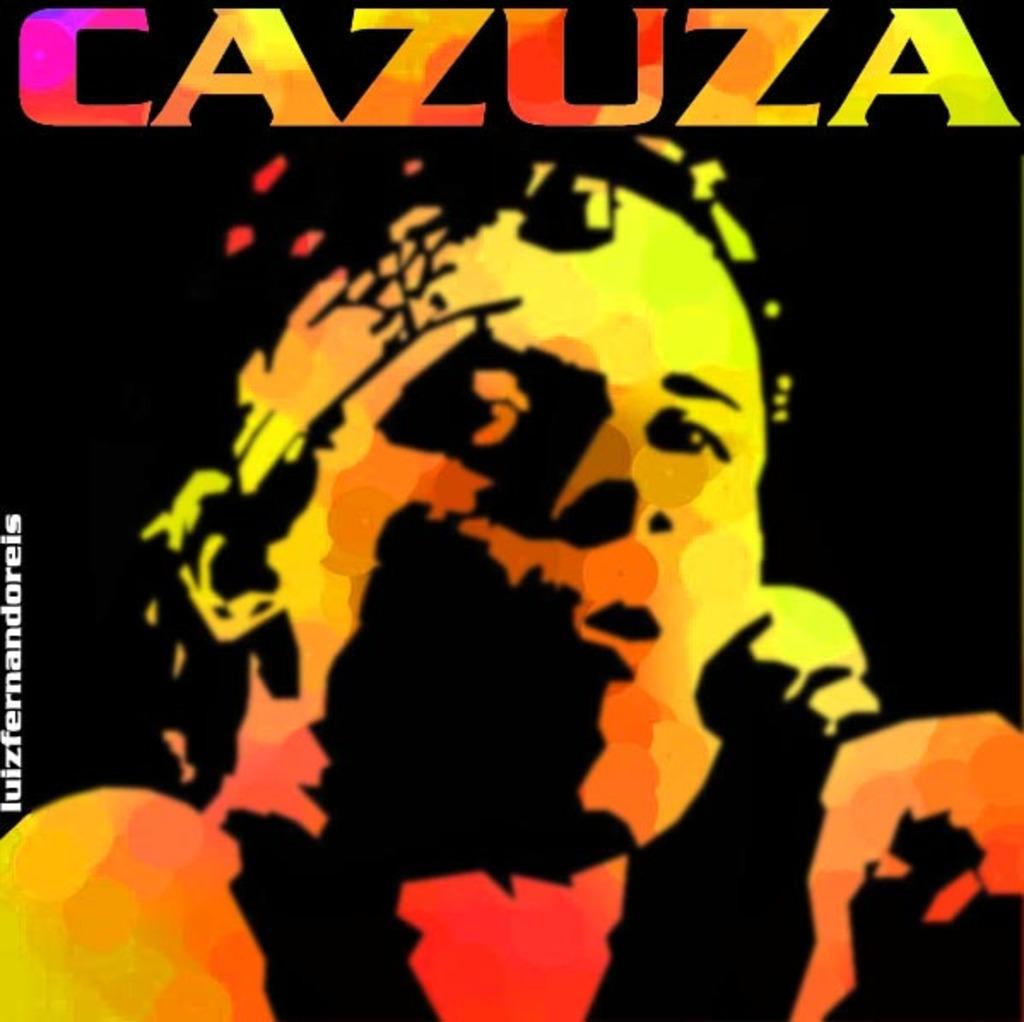What is the name on the photo?
Make the answer very short. Cazuza. Is cazuza a brazilian word?
Ensure brevity in your answer.  Yes. 